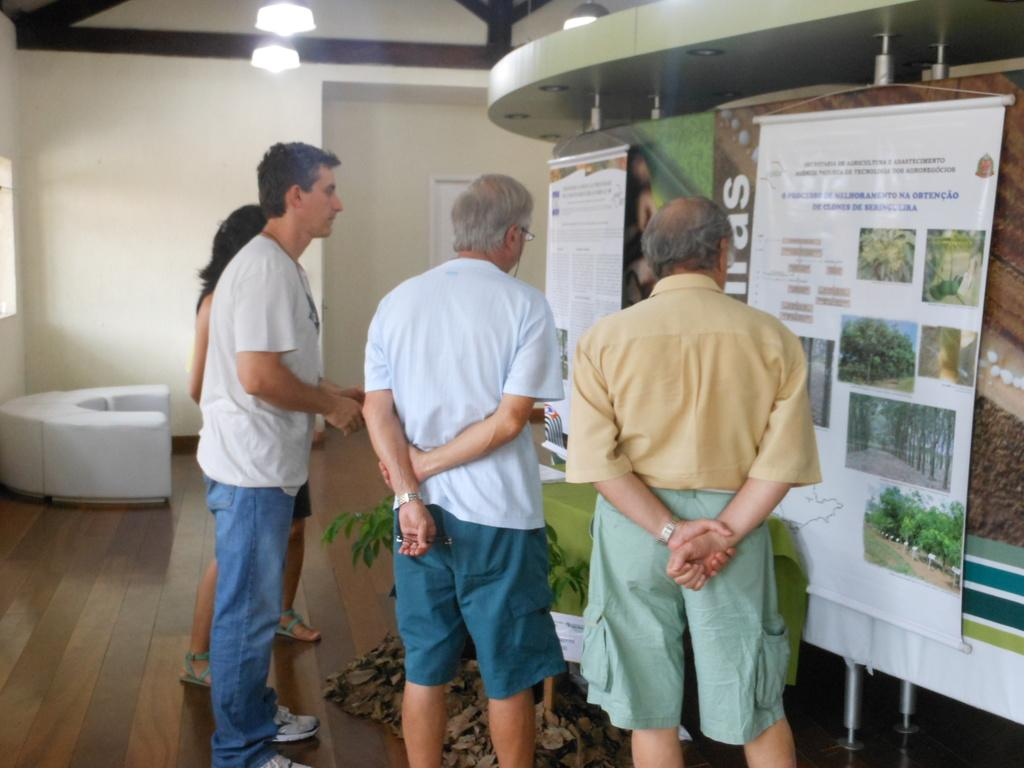How many people are present in the image? There are four persons standing in the image. What can be seen hanging in the image? There are banners in the image. What type of illumination is present in the image? There are lights in the image. What type of furniture is visible in the image? There is a chair in the image. What type of vegetation is present in the image? There is a plant in the image. What is visible in the background of the image? There is a wall in the background of the image. What type of blade is being used by the person on the left side of the image? There is no blade present in the image; it only shows four persons standing, banners, lights, a chair, a plant, and a wall in the background. 